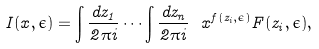Convert formula to latex. <formula><loc_0><loc_0><loc_500><loc_500>I ( x , \epsilon ) = \int \frac { d z _ { 1 } } { 2 \pi i } \cdots \int \frac { d z _ { n } } { 2 \pi i } \ x ^ { f ( z _ { i } , \epsilon ) } F ( z _ { i } , \epsilon ) ,</formula> 